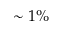<formula> <loc_0><loc_0><loc_500><loc_500>\sim 1 \%</formula> 